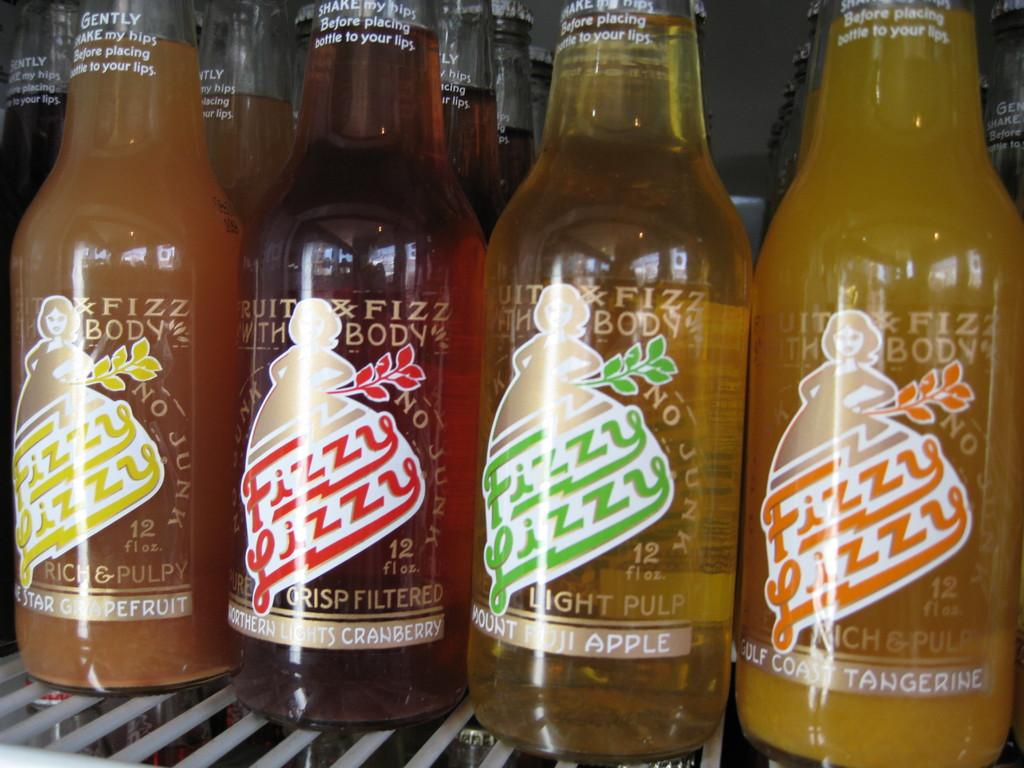<image>
Provide a brief description of the given image. Four bottles of differerent flavoured fizzy lizzy drinks. 